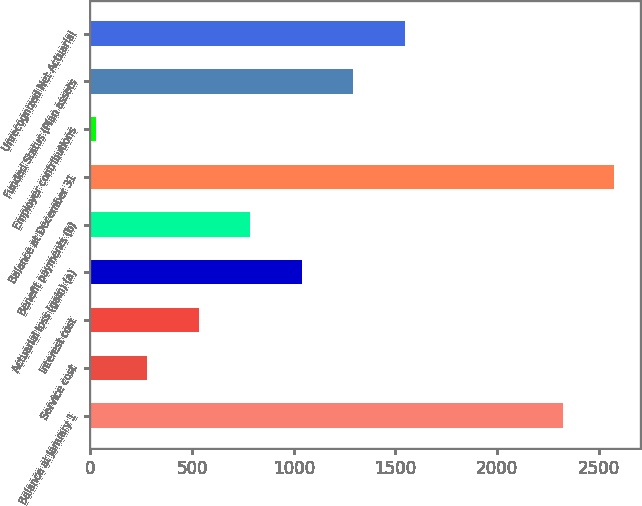Convert chart to OTSL. <chart><loc_0><loc_0><loc_500><loc_500><bar_chart><fcel>Balance at January 1<fcel>Service cost<fcel>Interest cost<fcel>Actuarial loss (gain) (a)<fcel>Benefit payments (b)<fcel>Balance at December 31<fcel>Employer contributions<fcel>Funded Status (Plan assets<fcel>Unrecognized Net Actuarial<nl><fcel>2321<fcel>279.4<fcel>532.8<fcel>1039.6<fcel>786.2<fcel>2574.4<fcel>26<fcel>1293<fcel>1546.4<nl></chart> 